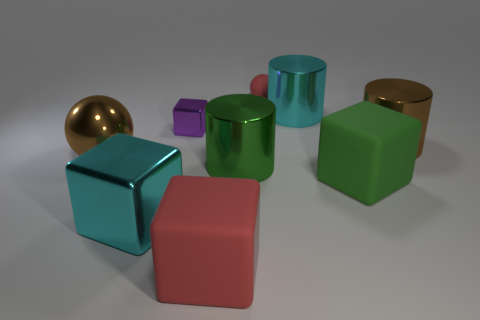Subtract all large blocks. How many blocks are left? 1 Subtract all green cylinders. How many cylinders are left? 2 Subtract all cylinders. How many objects are left? 6 Subtract 3 cylinders. How many cylinders are left? 0 Subtract all green cylinders. Subtract all purple balls. How many cylinders are left? 2 Subtract all blue balls. How many yellow cylinders are left? 0 Subtract all small purple blocks. Subtract all cyan metal blocks. How many objects are left? 7 Add 5 big cyan things. How many big cyan things are left? 7 Add 7 small balls. How many small balls exist? 8 Subtract 1 brown spheres. How many objects are left? 8 